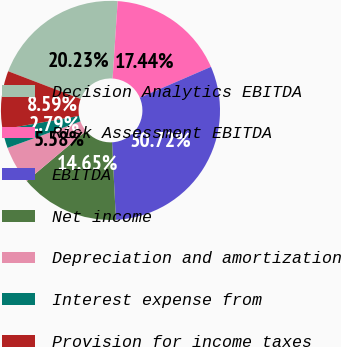<chart> <loc_0><loc_0><loc_500><loc_500><pie_chart><fcel>Decision Analytics EBITDA<fcel>Risk Assessment EBITDA<fcel>EBITDA<fcel>Net income<fcel>Depreciation and amortization<fcel>Interest expense from<fcel>Provision for income taxes<nl><fcel>20.23%<fcel>17.44%<fcel>30.72%<fcel>14.65%<fcel>5.58%<fcel>2.79%<fcel>8.59%<nl></chart> 